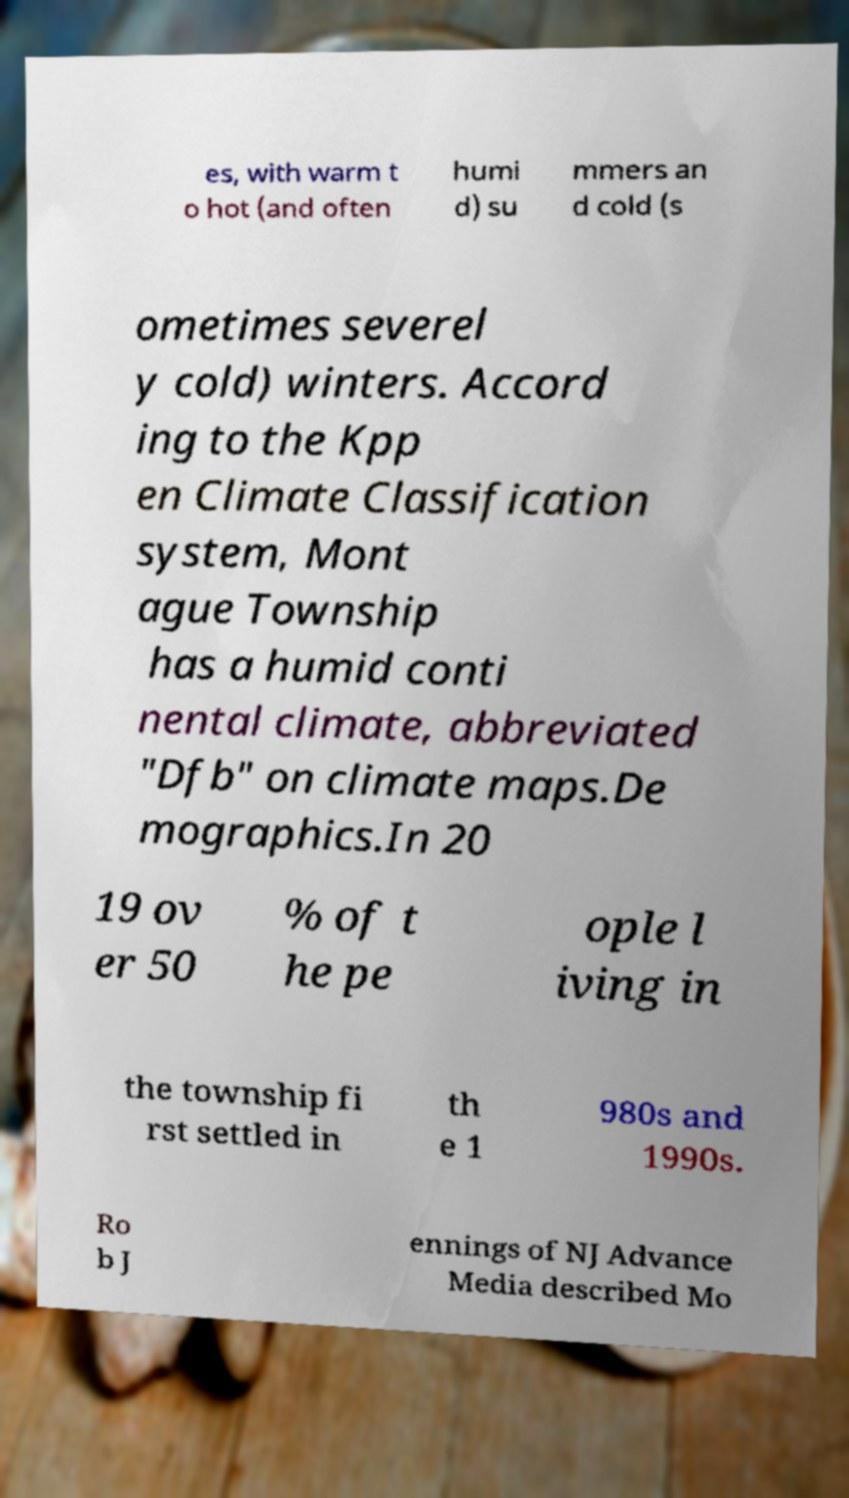Can you accurately transcribe the text from the provided image for me? es, with warm t o hot (and often humi d) su mmers an d cold (s ometimes severel y cold) winters. Accord ing to the Kpp en Climate Classification system, Mont ague Township has a humid conti nental climate, abbreviated "Dfb" on climate maps.De mographics.In 20 19 ov er 50 % of t he pe ople l iving in the township fi rst settled in th e 1 980s and 1990s. Ro b J ennings of NJ Advance Media described Mo 